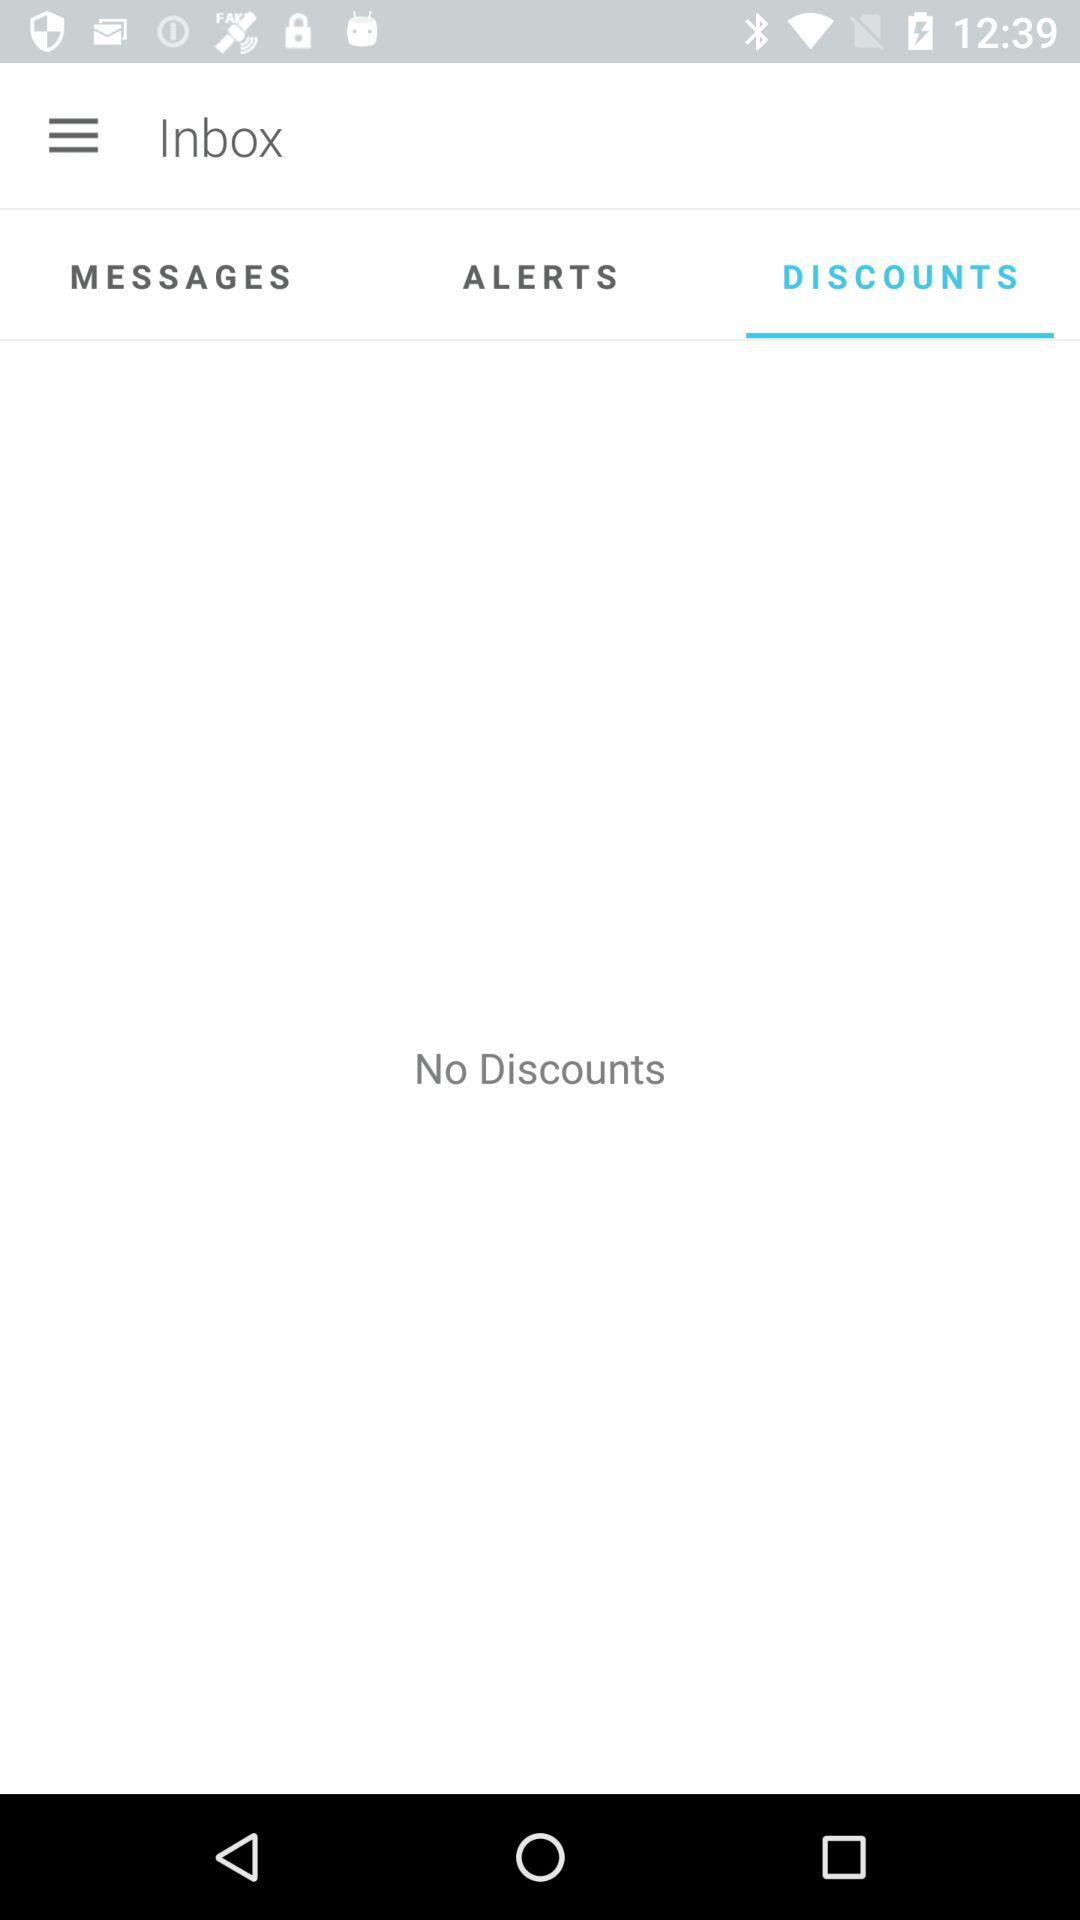Which tab is selected? The selected tab is "DISCOUNTS". 